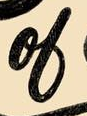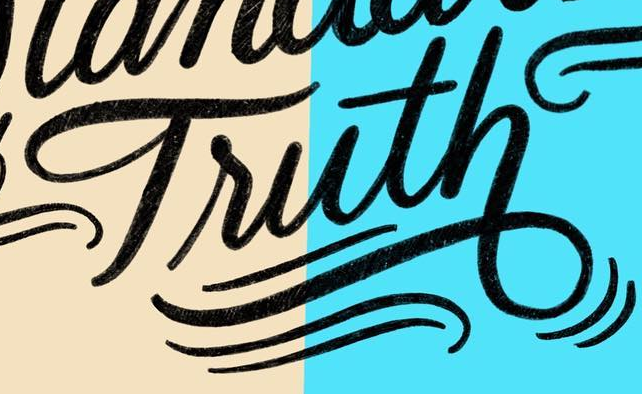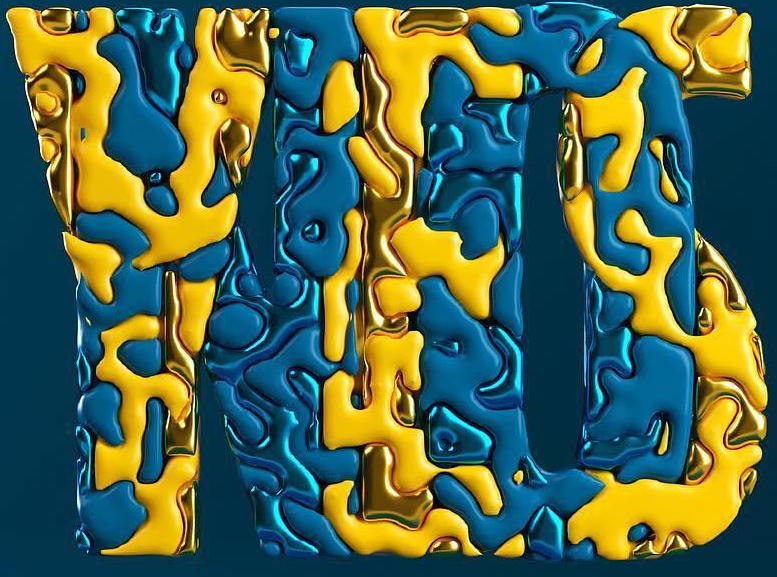What text appears in these images from left to right, separated by a semicolon? ol; Truth; YES 